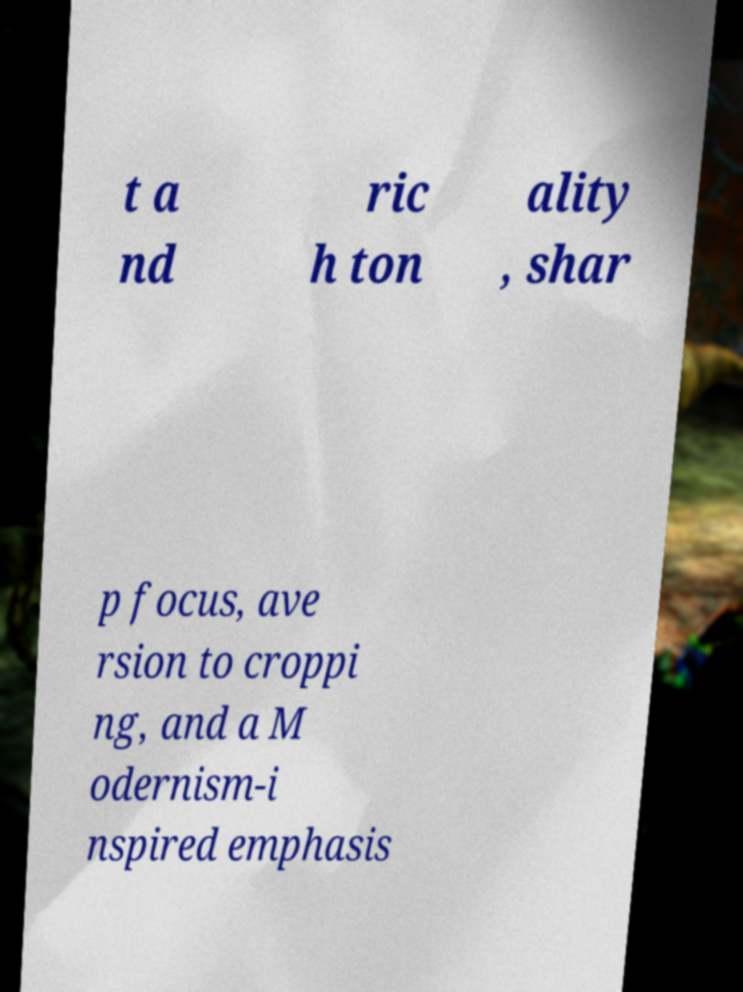Could you extract and type out the text from this image? t a nd ric h ton ality , shar p focus, ave rsion to croppi ng, and a M odernism-i nspired emphasis 